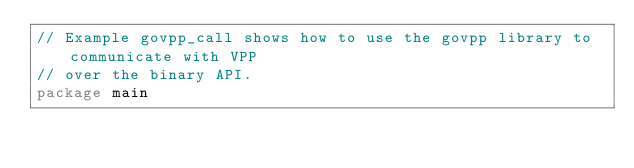Convert code to text. <code><loc_0><loc_0><loc_500><loc_500><_Go_>// Example govpp_call shows how to use the govpp library to communicate with VPP
// over the binary API.
package main
</code> 